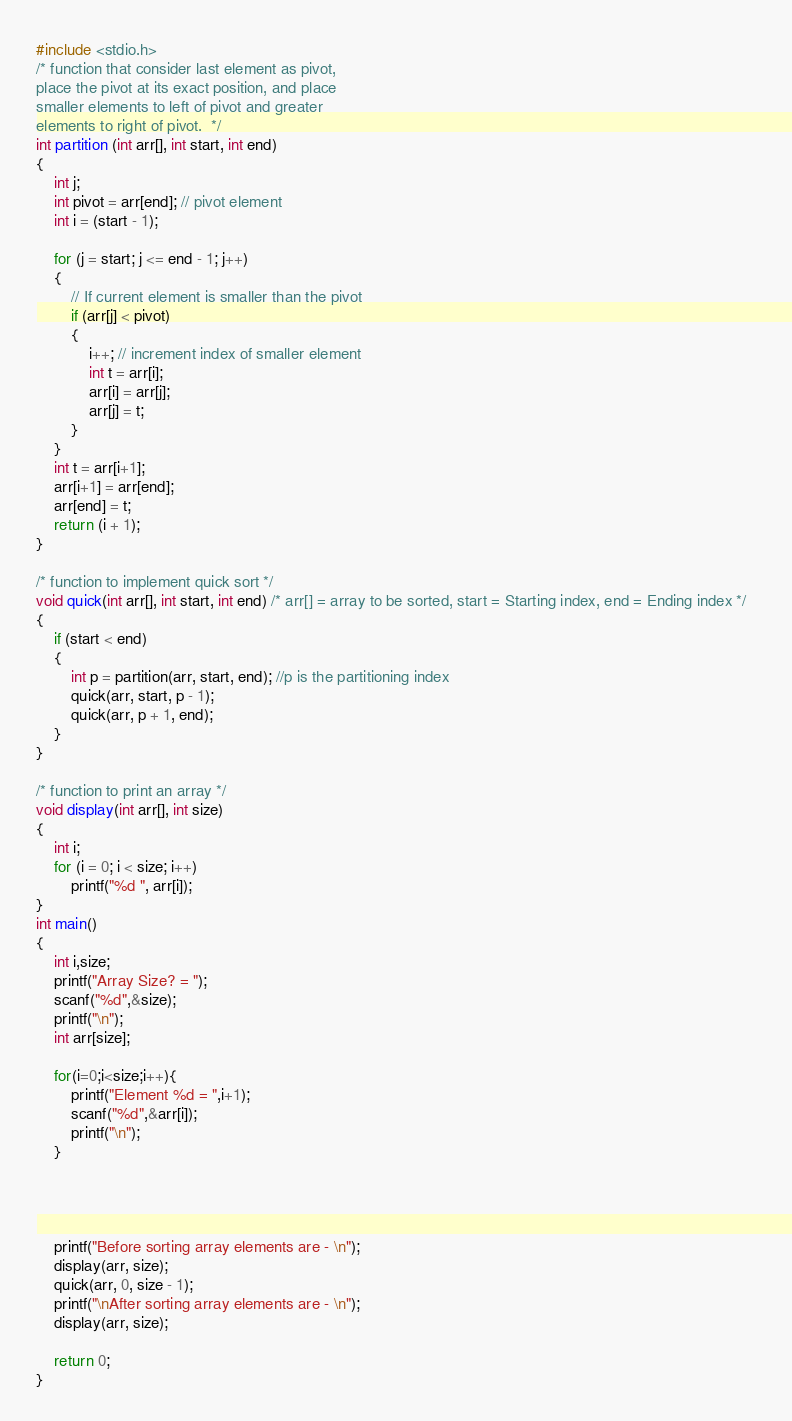<code> <loc_0><loc_0><loc_500><loc_500><_C_>#include <stdio.h>  
/* function that consider last element as pivot,  
place the pivot at its exact position, and place  
smaller elements to left of pivot and greater  
elements to right of pivot.  */  
int partition (int arr[], int start, int end)  
{  
	int j;
    int pivot = arr[end]; // pivot element  
    int i = (start - 1);  
  
    for (j = start; j <= end - 1; j++)  
    {  
        // If current element is smaller than the pivot  
        if (arr[j] < pivot)  
        {  
            i++; // increment index of smaller element  
            int t = arr[i];  
            arr[i] = arr[j];  
            arr[j] = t;  
        }  
    }  
    int t = arr[i+1];  
    arr[i+1] = arr[end];  
    arr[end] = t;  
    return (i + 1);  
}  
  
/* function to implement quick sort */  
void quick(int arr[], int start, int end) /* arr[] = array to be sorted, start = Starting index, end = Ending index */  
{  
    if (start < end)  
    {  
        int p = partition(arr, start, end); //p is the partitioning index  
        quick(arr, start, p - 1);  
        quick(arr, p + 1, end);  
    }  
}  
  
/* function to print an array */  
void display(int arr[], int size)  
{  
    int i;  
    for (i = 0; i < size; i++)  
        printf("%d ", arr[i]);  
}  
int main()  
{  
    int i,size;
	printf("Array Size? = ");
	scanf("%d",&size);
	printf("\n");
	int arr[size];
	
	for(i=0;i<size;i++){
		printf("Element %d = ",i+1);
		scanf("%d",&arr[i]);
		printf("\n");
	} 
   
   
   
   
    printf("Before sorting array elements are - \n");  
    display(arr, size);  
    quick(arr, 0, size - 1);  
    printf("\nAfter sorting array elements are - \n");    
    display(arr, size);  
      
    return 0;  
}  
</code> 